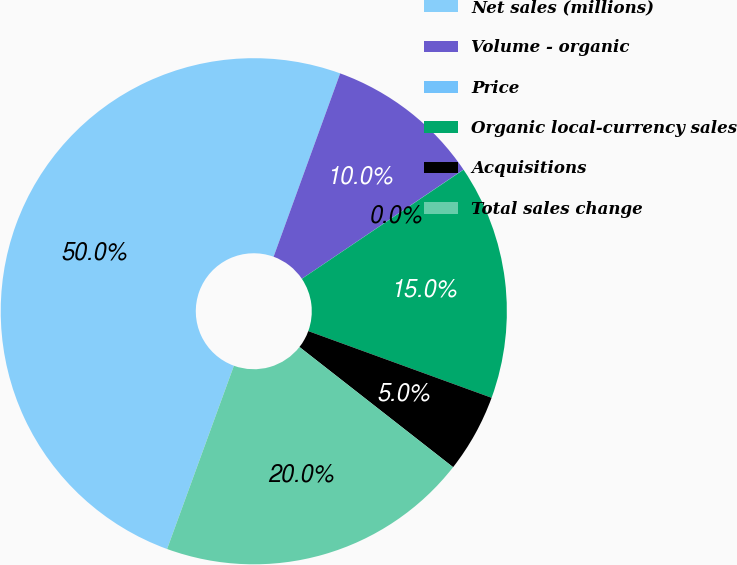<chart> <loc_0><loc_0><loc_500><loc_500><pie_chart><fcel>Net sales (millions)<fcel>Volume - organic<fcel>Price<fcel>Organic local-currency sales<fcel>Acquisitions<fcel>Total sales change<nl><fcel>49.98%<fcel>10.0%<fcel>0.01%<fcel>15.0%<fcel>5.01%<fcel>20.0%<nl></chart> 